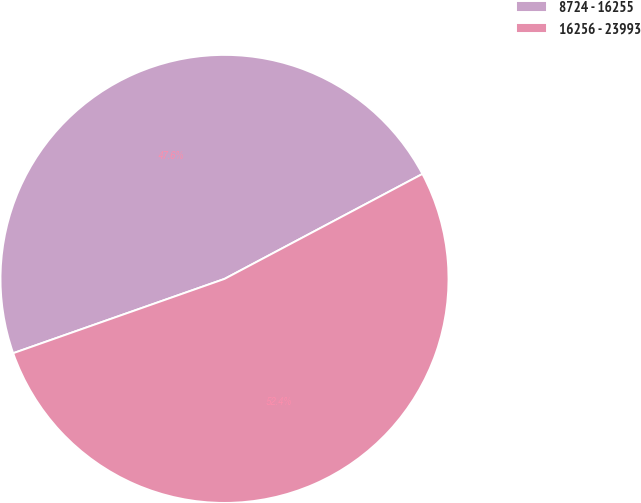<chart> <loc_0><loc_0><loc_500><loc_500><pie_chart><fcel>8724 - 16255<fcel>16256 - 23993<nl><fcel>47.62%<fcel>52.38%<nl></chart> 